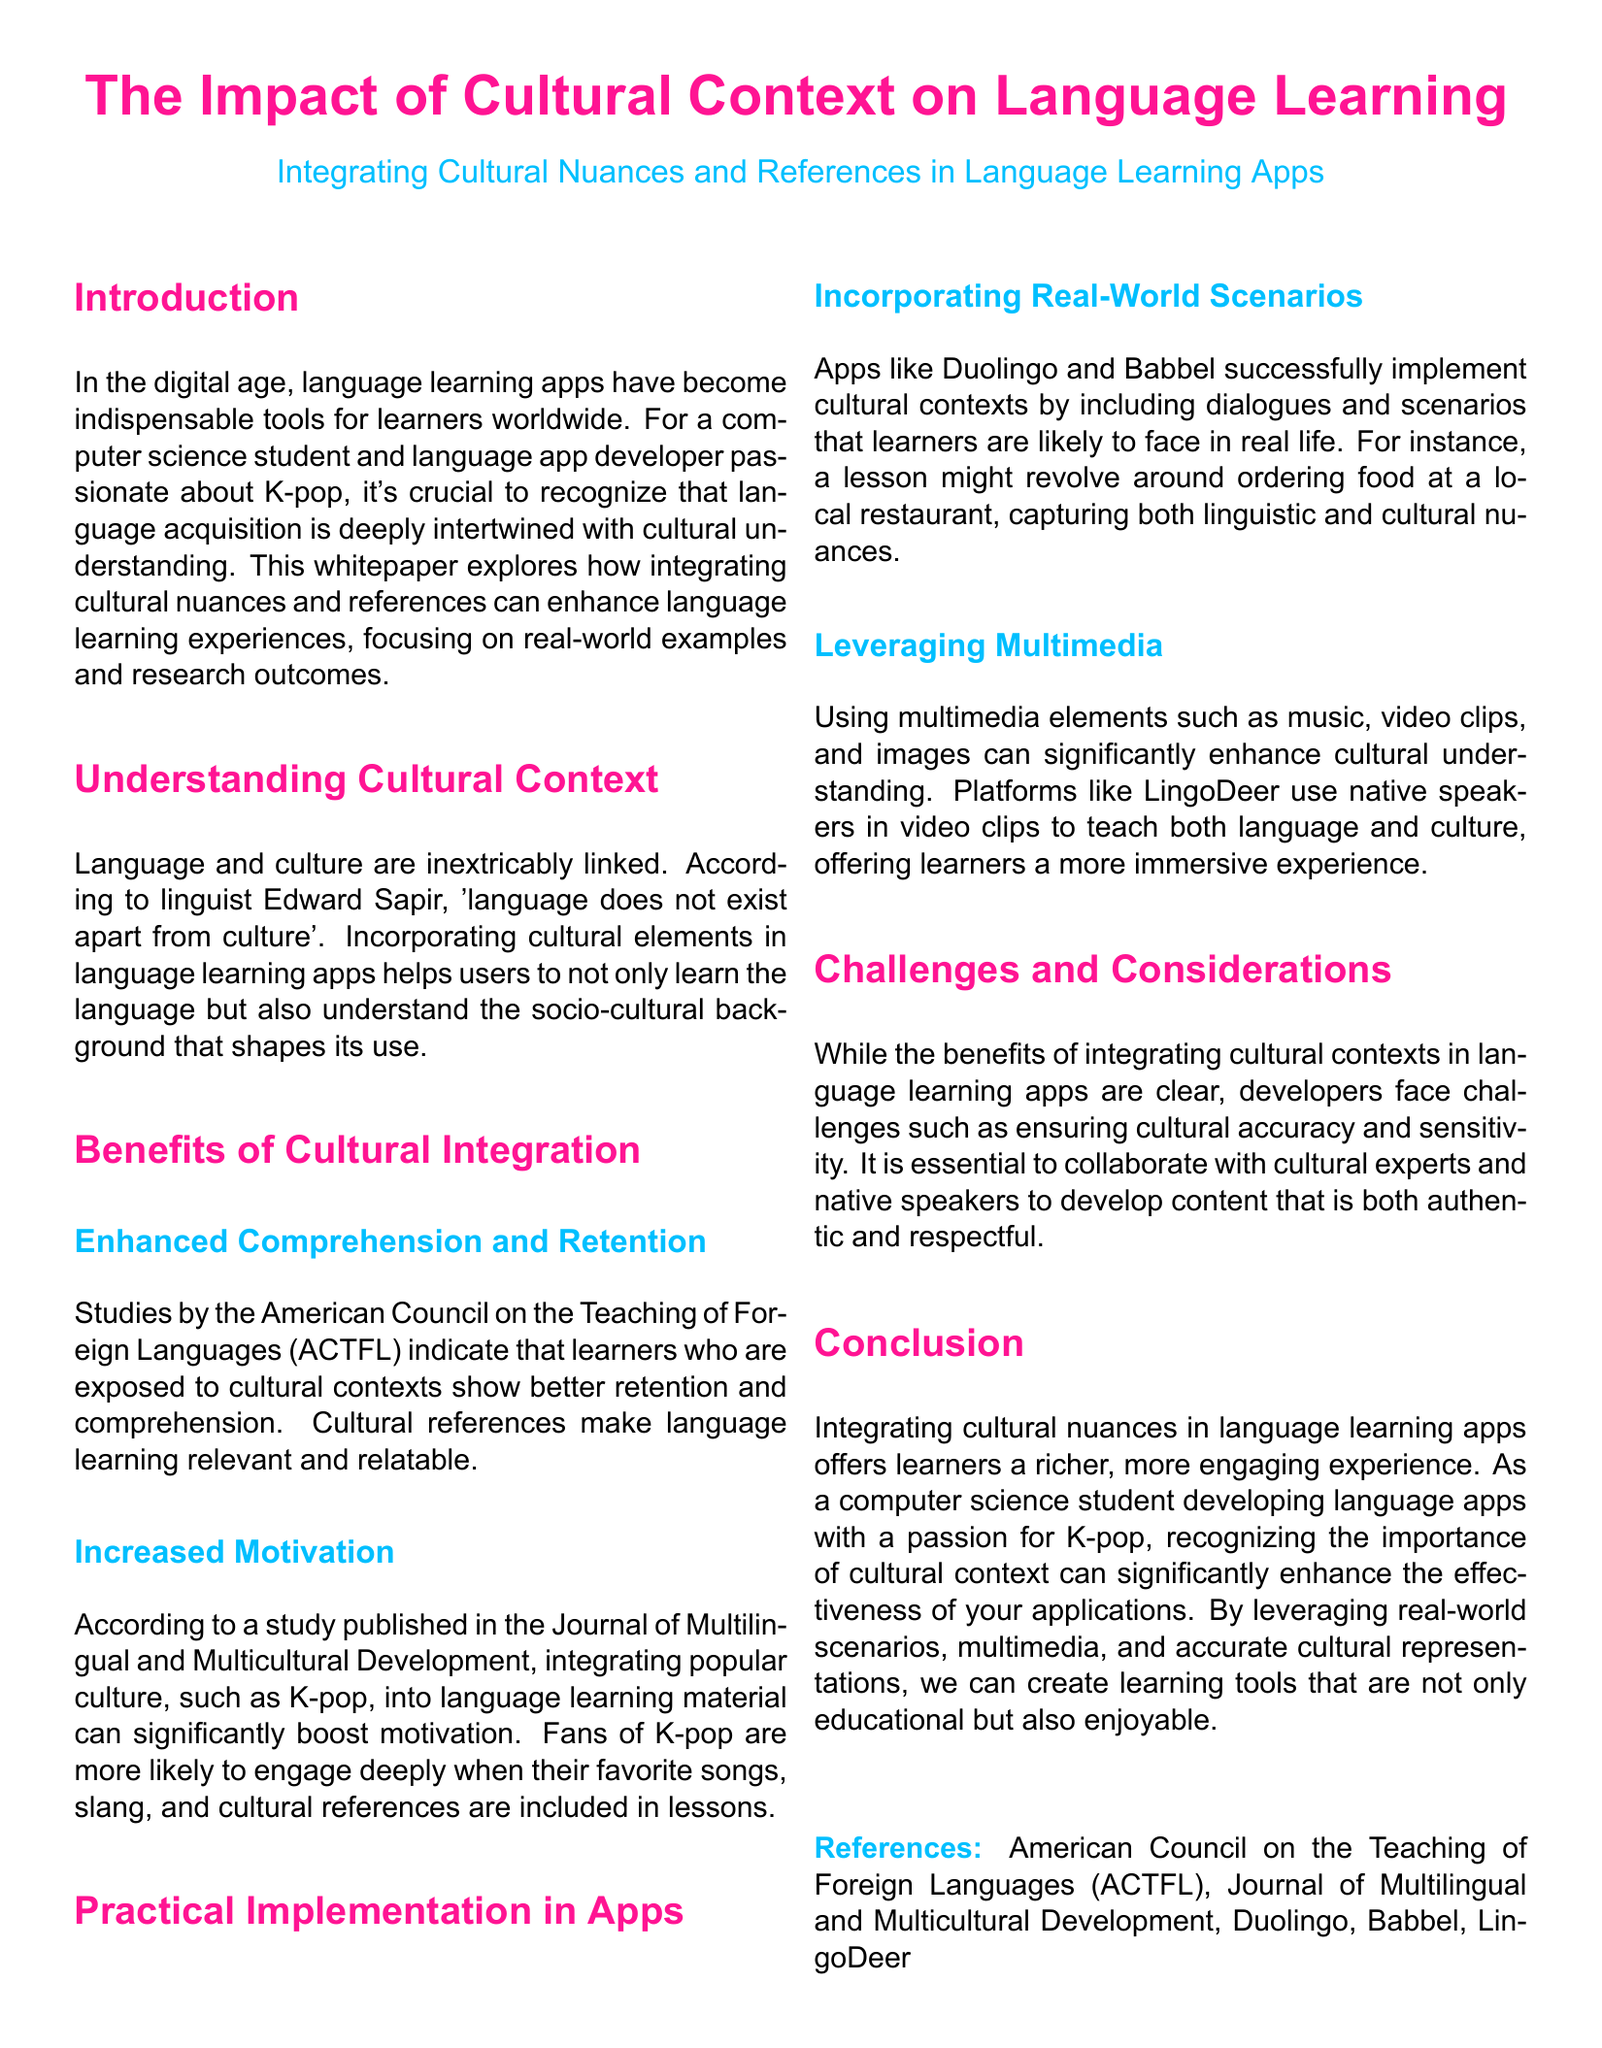What is the title of the whitepaper? The title is found at the top of the document, indicating the main topic it addresses.
Answer: The Impact of Cultural Context on Language Learning What crucial aspect helps enhance language learning, according to the document? The document emphasizes the importance of cultural integration in language learning.
Answer: Cultural understanding Which organization conducted studies referenced in the document? The studies are mentioned under the section on benefits, highlighting a credible source of information.
Answer: American Council on the Teaching of Foreign Languages What popular culture element is specifically mentioned as a motivational tool in language learning? The document cites an example of popular culture that can enhance learner engagement.
Answer: K-pop What is one challenge mentioned regarding the integration of cultural contexts? The document outlines a specific difficulty that developers of language apps may encounter.
Answer: Cultural accuracy How do apps like Duolingo and Babbel integrate cultural contexts? The whitepaper provides examples of how these apps implement cultural elements in their lessons.
Answer: Real-world scenarios What is one multimedia element suggested for enhancing cultural understanding? The document lists a type of content that can be used to provide a richer language learning experience.
Answer: Music Who is the intended audience for the whitepaper? The introduction mentions a specific group of individuals for whom the information is particularly relevant.
Answer: Computer science students 